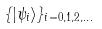<formula> <loc_0><loc_0><loc_500><loc_500>\{ | \psi _ { i } \rangle \} _ { i = 0 , 1 , 2 , \dots }</formula> 